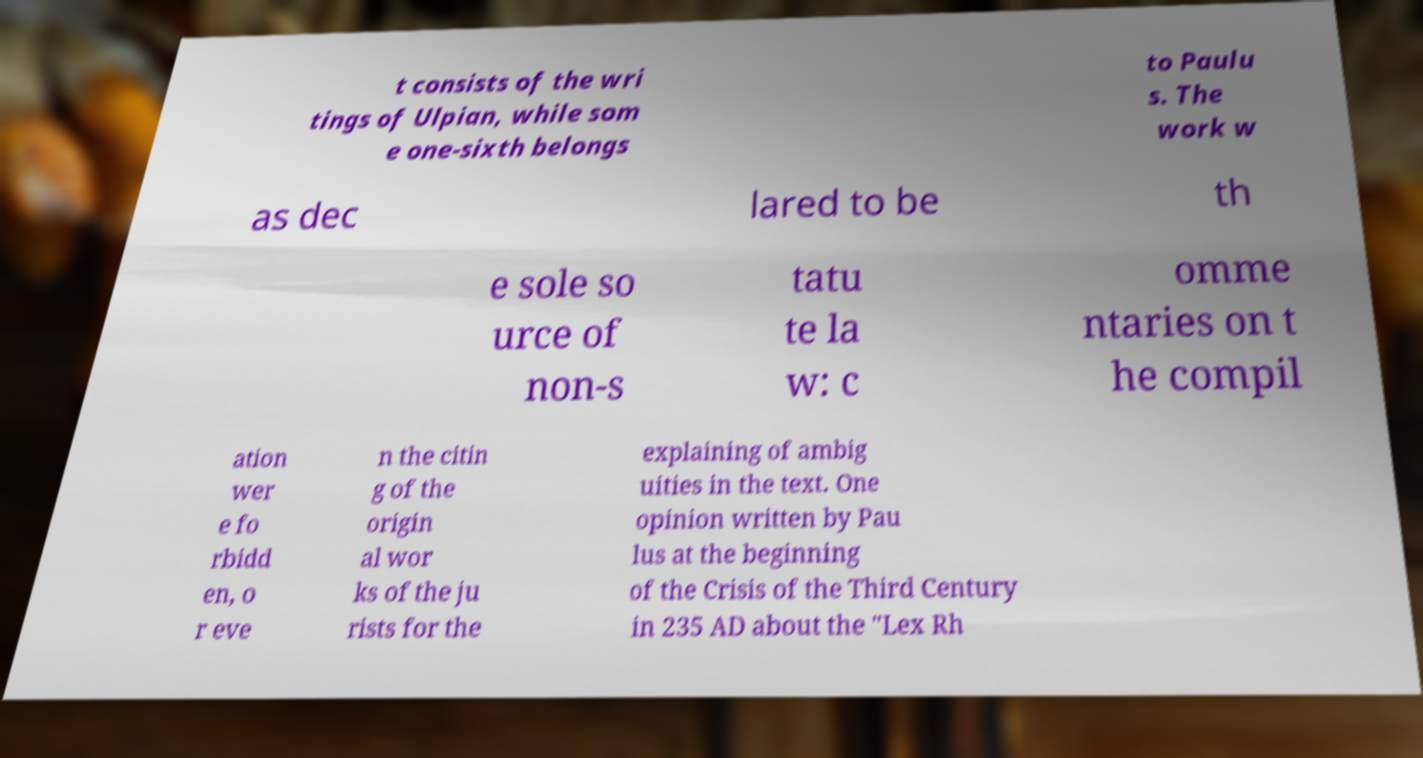Could you assist in decoding the text presented in this image and type it out clearly? t consists of the wri tings of Ulpian, while som e one-sixth belongs to Paulu s. The work w as dec lared to be th e sole so urce of non-s tatu te la w: c omme ntaries on t he compil ation wer e fo rbidd en, o r eve n the citin g of the origin al wor ks of the ju rists for the explaining of ambig uities in the text. One opinion written by Pau lus at the beginning of the Crisis of the Third Century in 235 AD about the "Lex Rh 